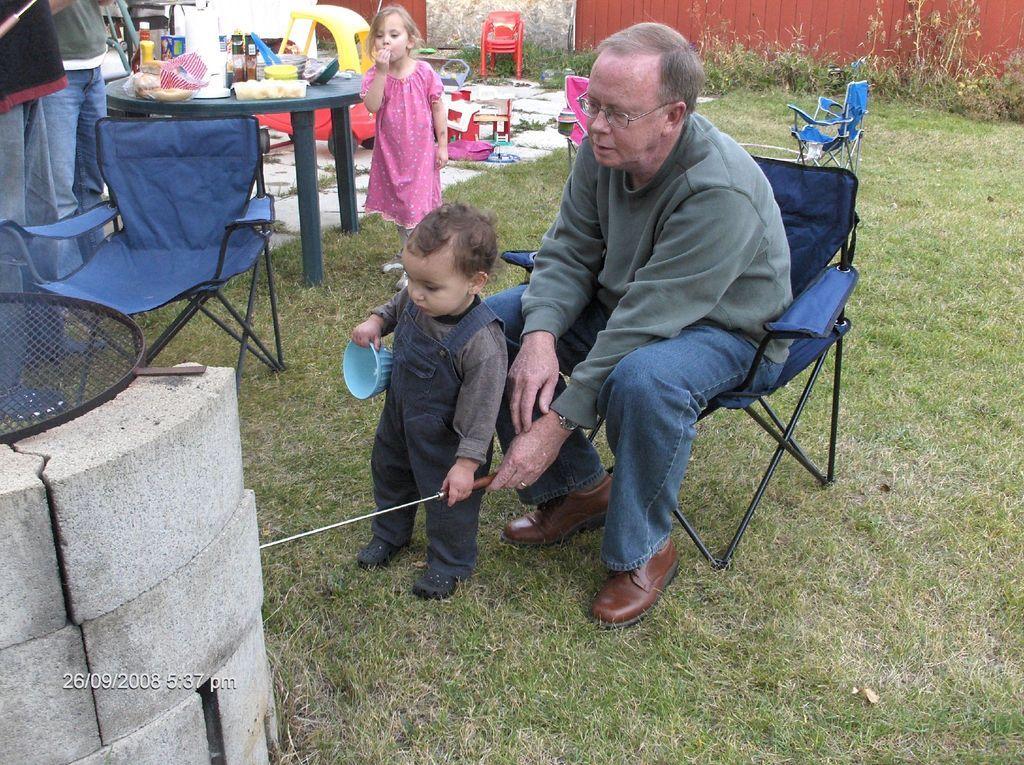Please provide a concise description of this image. In the middle of the image we can see a person sitting on a chair, place on the ground. A kid holding a stick in his hand. To the left side, we can see two persons standing in front of a table on which several food items are placed a chair is placed on the ground. A metal mesh placed on the brick. In the background we can see a kid standing and group of plants. 